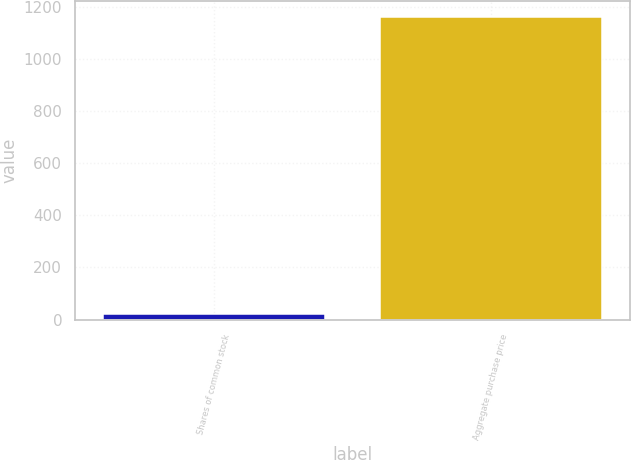Convert chart. <chart><loc_0><loc_0><loc_500><loc_500><bar_chart><fcel>Shares of common stock<fcel>Aggregate purchase price<nl><fcel>22.3<fcel>1161.9<nl></chart> 